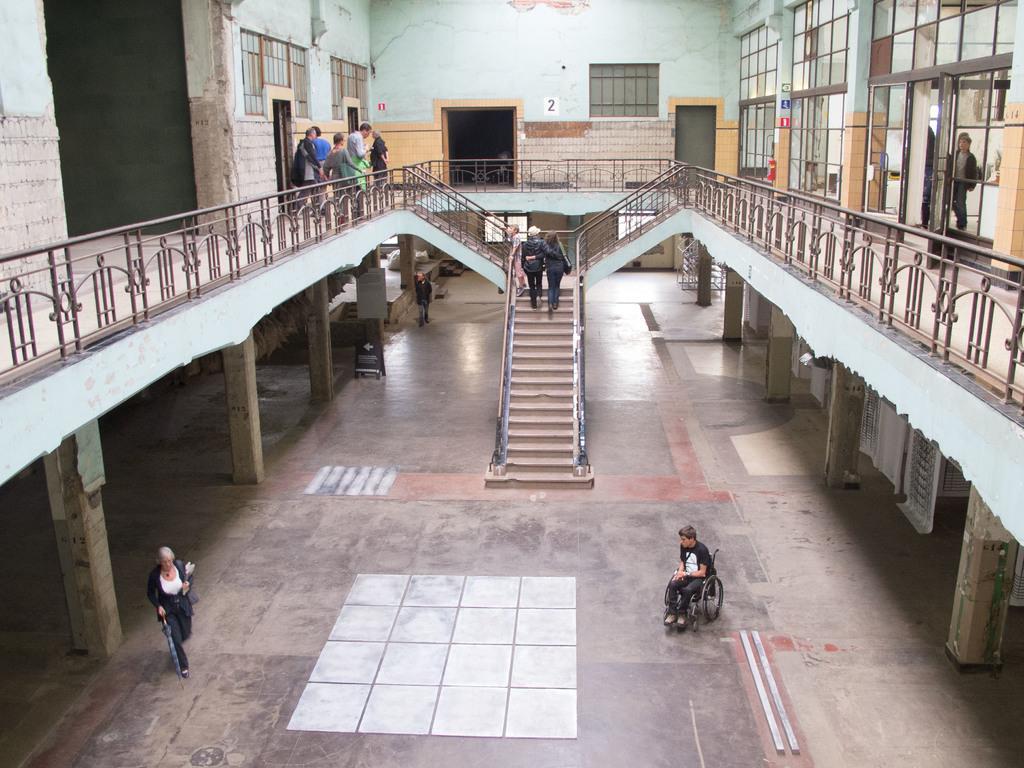Describe this image in one or two sentences. This picture shows a building and we see couple of them climbing the stairs and we see a woman walking and holding a umbrella in her hand and we see a man seated on the wheelchair and we see windows and doors and few people standing. 